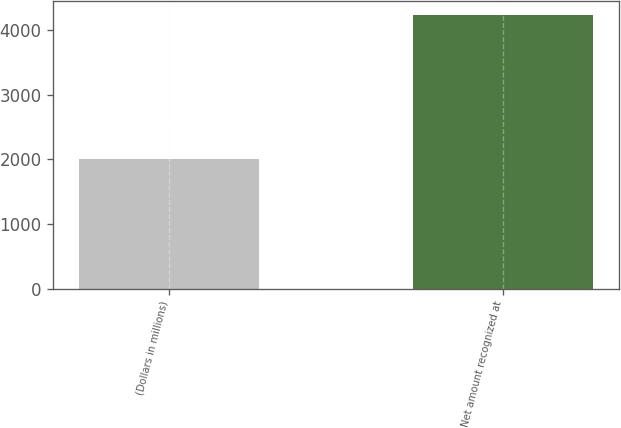Convert chart. <chart><loc_0><loc_0><loc_500><loc_500><bar_chart><fcel>(Dollars in millions)<fcel>Net amount recognized at<nl><fcel>2005<fcel>4237<nl></chart> 